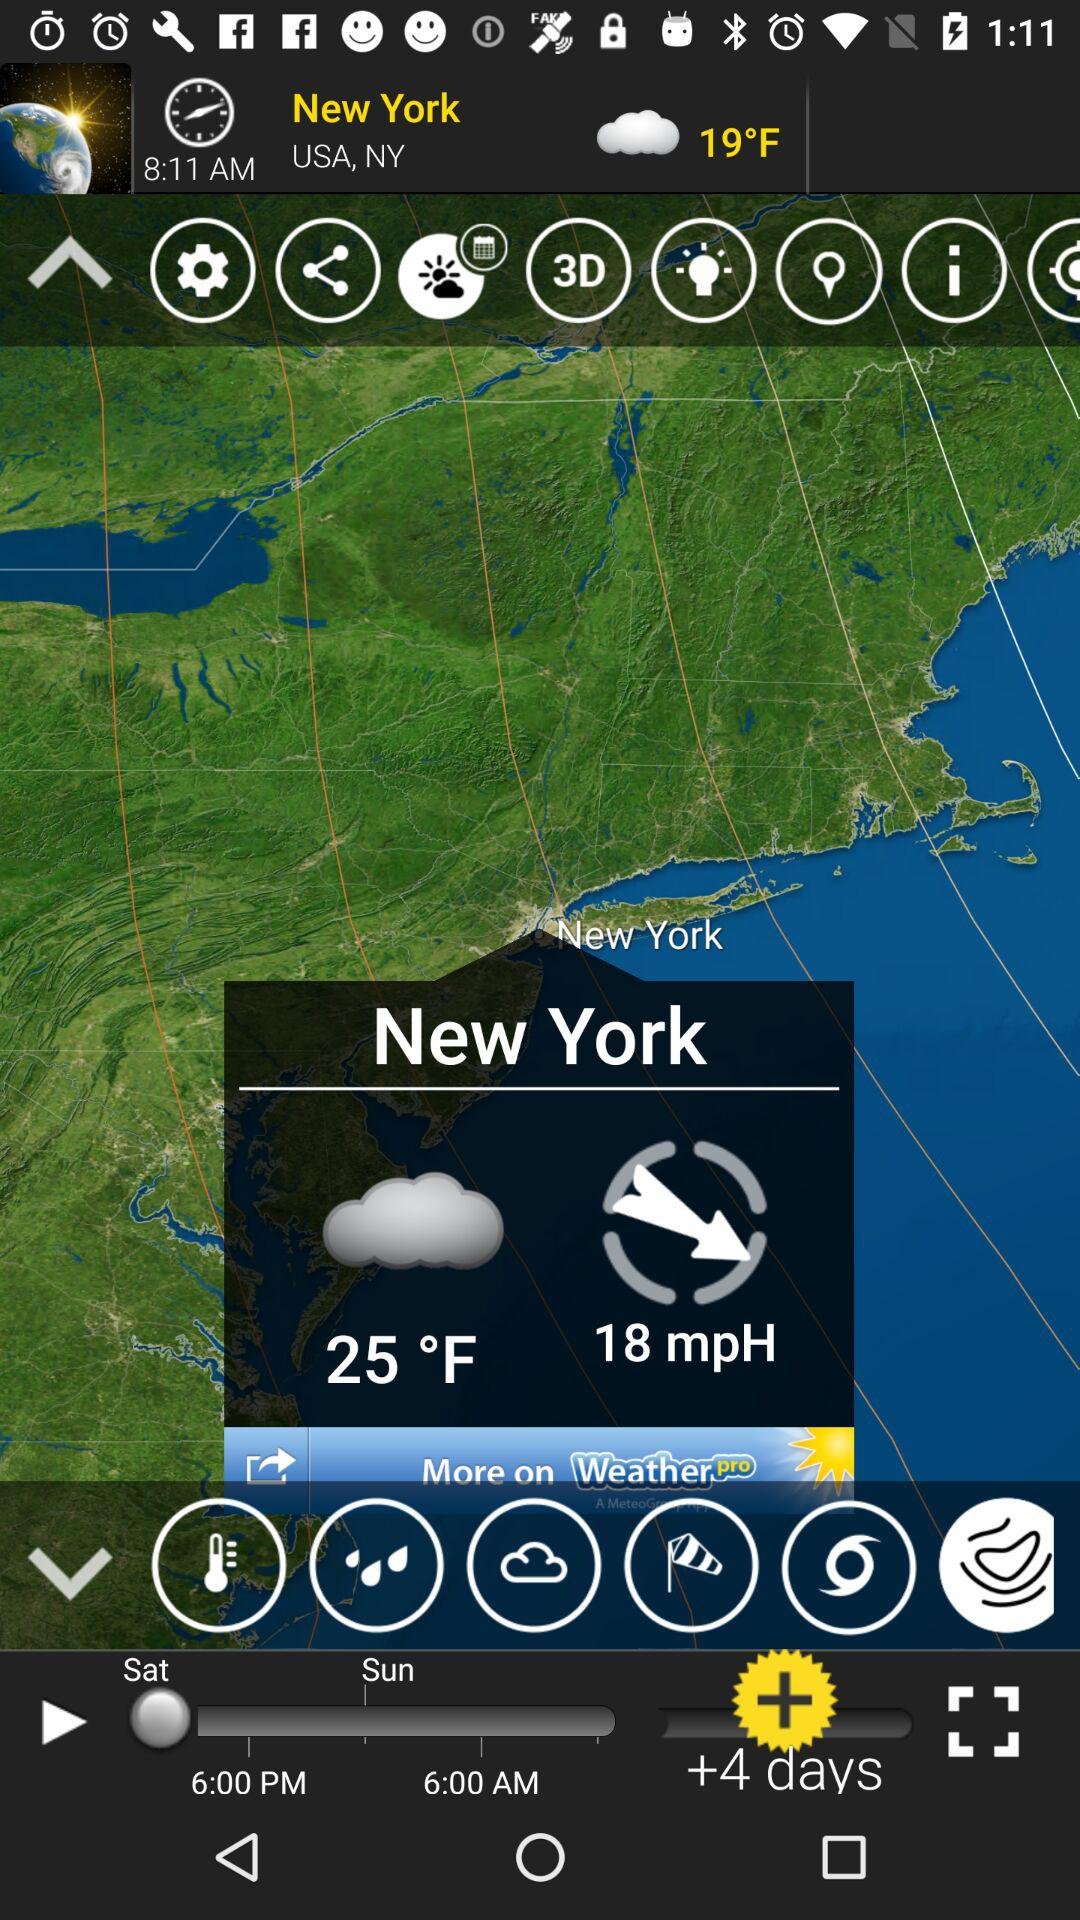What is the current location? The current location is New York, USA. 